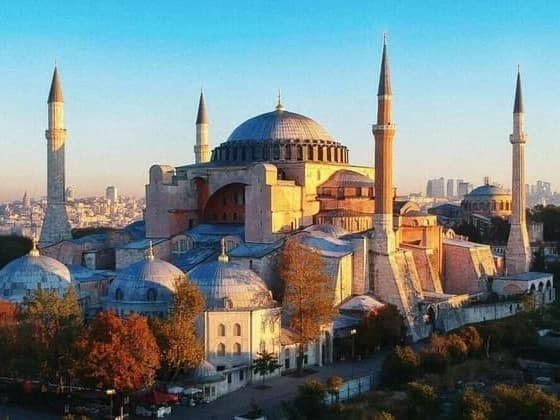Describe the architectural styles present in this building. The Hagia Sophia is a masterpiece of architectural fusion, showcasing both Byzantine and Ottoman influences. The large central dome, supported by pendentives, is a hallmark of Byzantine architecture, symbolizing the heavens and the grandeur of the Byzantine Empire. The four minarets, added after the Ottoman conquest, reflect Islamic architectural traditions, emphasizing verticality and serving as visual markers for the mosque. The combination of these styles in one structure signifies the significant historical transitions the building has undergone, from a Christian basilica to an imperial mosque, and now a museum. What are some unique innovations in the construction of the Hagia Sophia? The Hagia Sophia boasts several groundbreaking architectural innovations. One of the most remarkable is the use of pendentives, which enabled the transition from a square base to the massive circular dome. This innovative structural technique was pioneering at the time and allowed for the creation of an expansive, open interior space unobstructed by columns. Additionally, the incorporation of light, achieved through a series of strategically placed windows at the base of the dome, creates an ethereal, floating effect, enhancing the spiritual ambiance within the structure. These innovations not only demonstrate advanced engineering skills but also contribute significantly to the building's aesthetic and functional excellence. Imagine what it was like during the height of the Byzantine Empire when Hagia Sophia was first constructed. Describe a day inside the building. During the height of the Byzantine Empire, the Hagia Sophia would have been a bustling center of religious and social activity. Imagine the air filled with the melodious chants of the choir, echoing through the vast interior, harmonizing with the light streaming in through the high windows, casting a divine glow upon the intricate gold mosaics and ornate decorations. The congregation, clad in rich Byzantine attire, would be enthralled by the grandeur of their surroundings. Priests in their elaborate vestments would conduct the liturgy, the scent of incense wafting through the space, mingling with the flickering light of countless candles. The ethereal atmosphere, coupled with the awe-inspiring architecture, would leave worshippers with a profound sense of spiritual upliftment and communal unity, making each visit an unforgettable experience. 